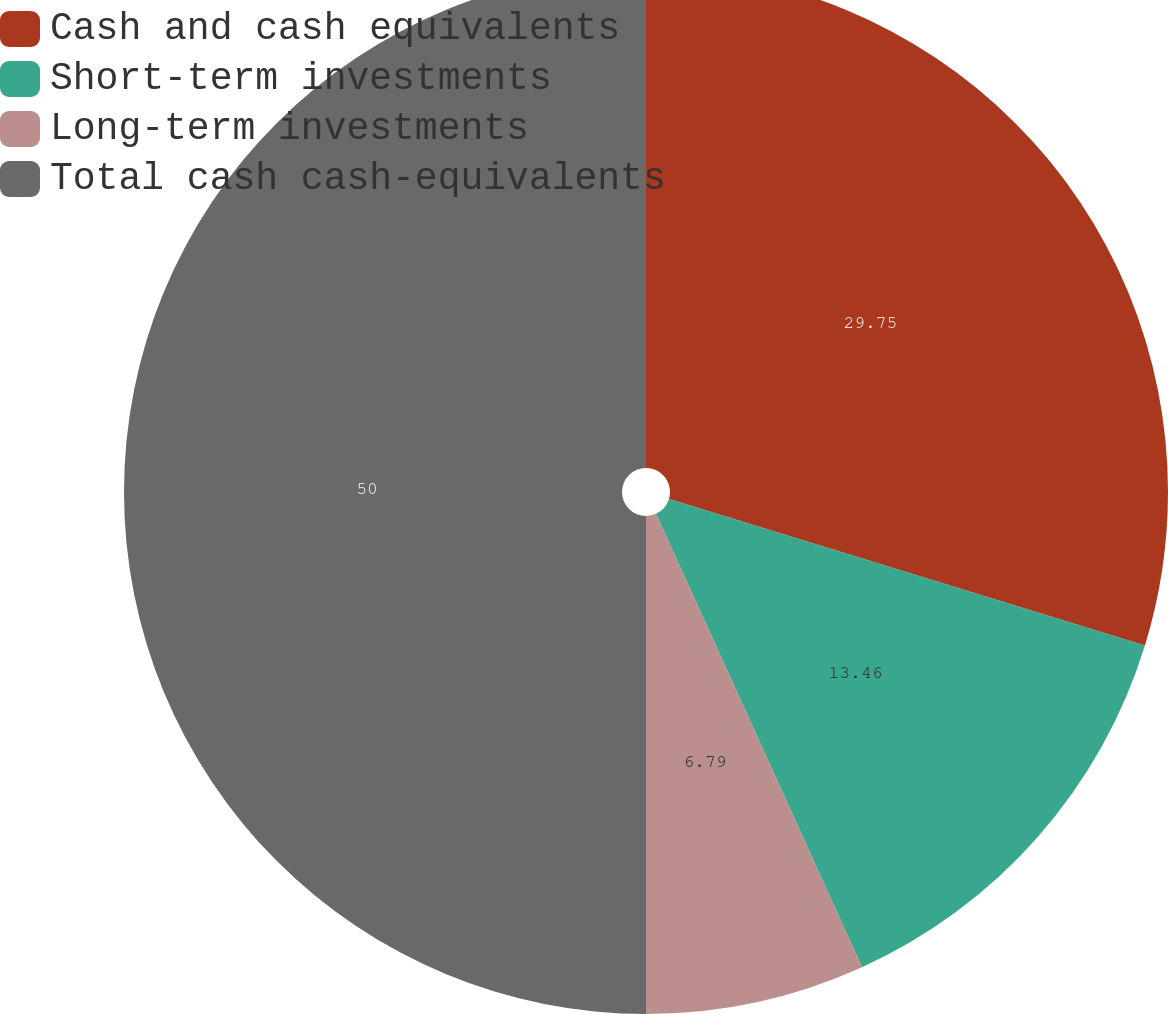<chart> <loc_0><loc_0><loc_500><loc_500><pie_chart><fcel>Cash and cash equivalents<fcel>Short-term investments<fcel>Long-term investments<fcel>Total cash cash-equivalents<nl><fcel>29.75%<fcel>13.46%<fcel>6.79%<fcel>50.0%<nl></chart> 